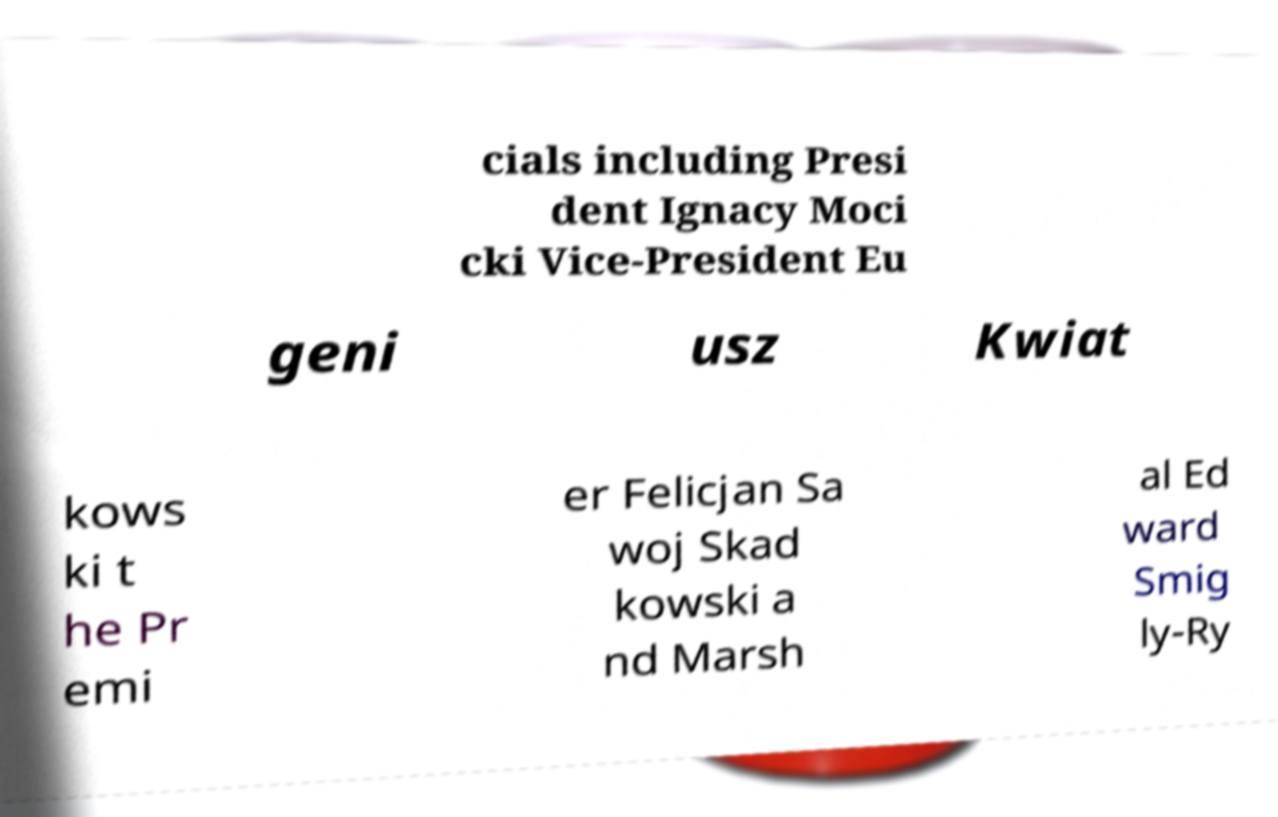There's text embedded in this image that I need extracted. Can you transcribe it verbatim? cials including Presi dent Ignacy Moci cki Vice-President Eu geni usz Kwiat kows ki t he Pr emi er Felicjan Sa woj Skad kowski a nd Marsh al Ed ward Smig ly-Ry 